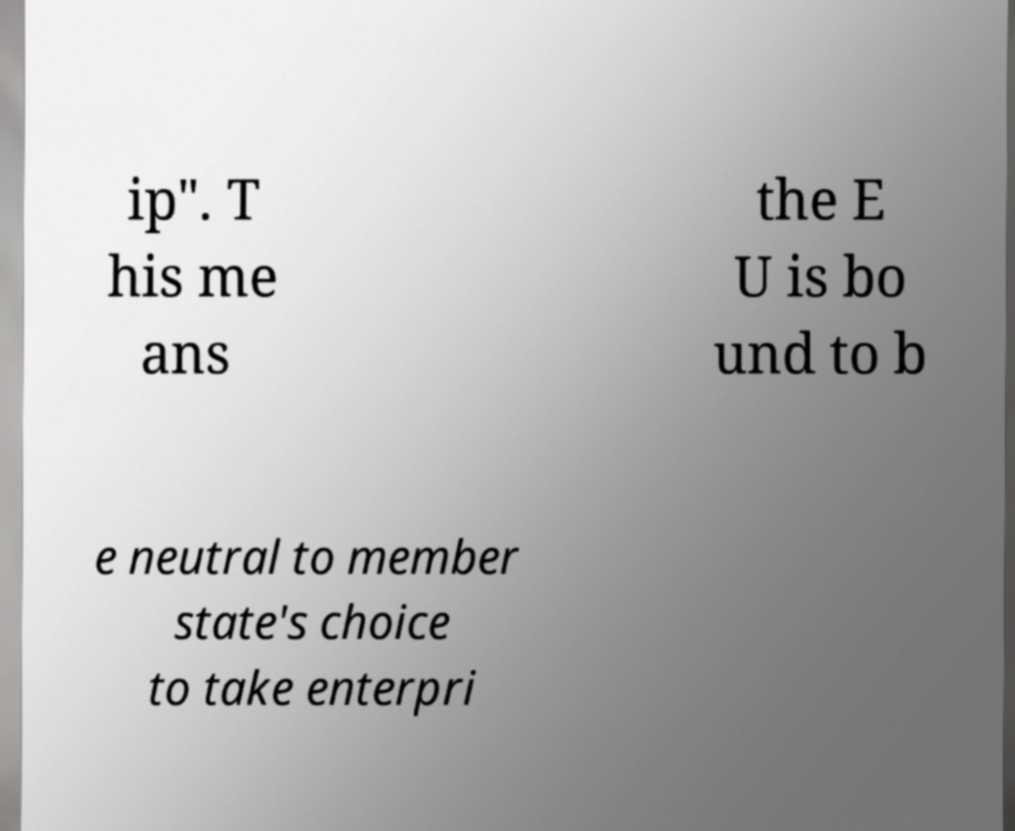Could you assist in decoding the text presented in this image and type it out clearly? ip". T his me ans the E U is bo und to b e neutral to member state's choice to take enterpri 